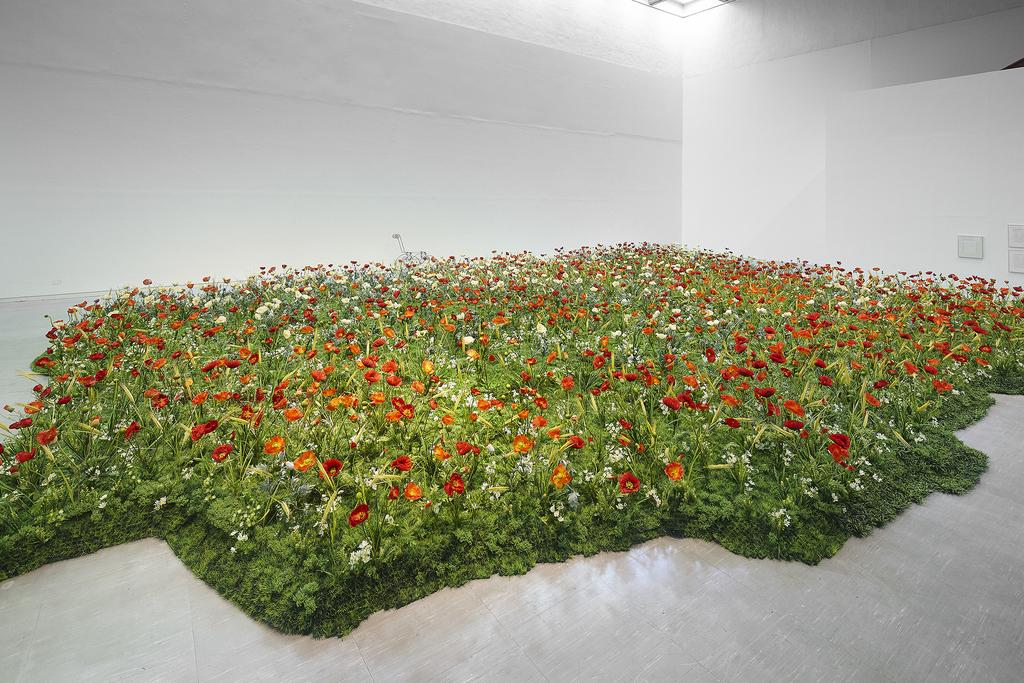What can be seen on the plants in the image? There are many flowers on the plants in the image. What is the source of light on the roof in the image? There is a light beam visible on the roof in the image. What is placed on the wall in the image? There is a frame placed on the wall in the image. How many clocks are present in the image? There are no clocks visible in the image. What is the distance between the town and the image? The image does not provide any information about the distance to a town, nor is there any town present in the image. 